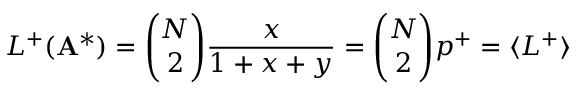Convert formula to latex. <formula><loc_0><loc_0><loc_500><loc_500>L ^ { + } ( A ^ { * } ) = \binom { N } { 2 } \frac { x } { 1 + x + y } = \binom { N } { 2 } p ^ { + } = \langle L ^ { + } \rangle</formula> 